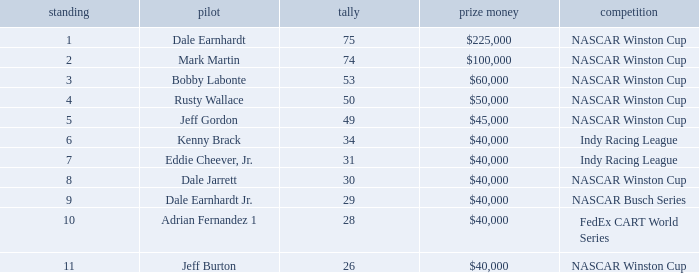In what series did Bobby Labonte drive? NASCAR Winston Cup. 